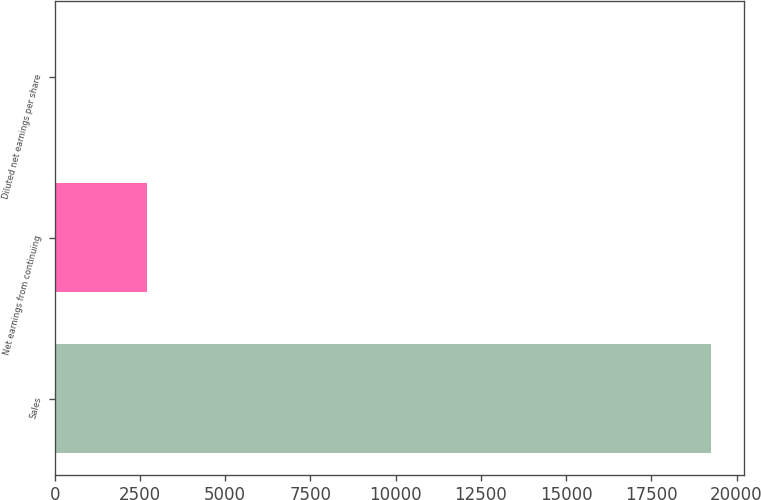<chart> <loc_0><loc_0><loc_500><loc_500><bar_chart><fcel>Sales<fcel>Net earnings from continuing<fcel>Diluted net earnings per share<nl><fcel>19263.1<fcel>2698.4<fcel>3.8<nl></chart> 